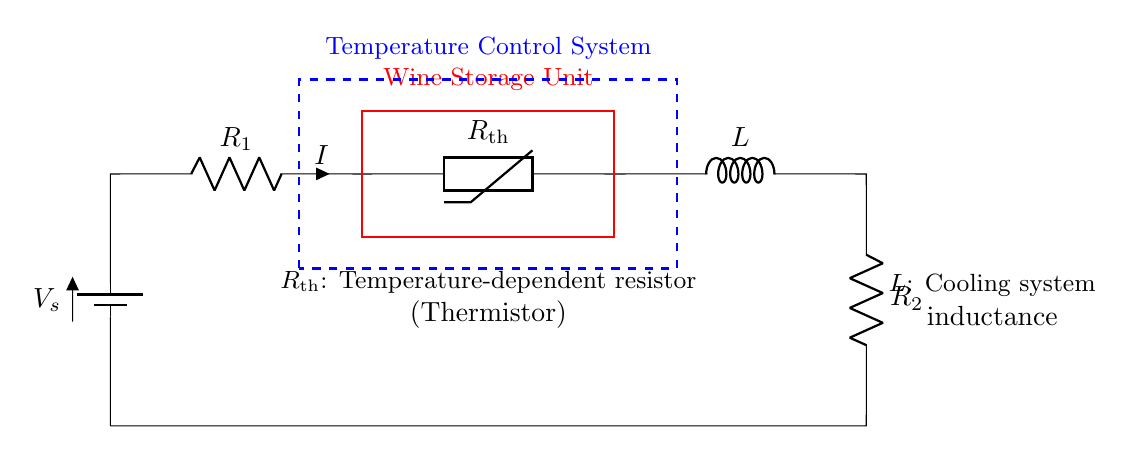What type of circuit is depicted? This circuit is a series circuit, as all components are connected in a single path, and the current flows through each component consecutively.
Answer: series circuit What component is represented by R1? R1 represents a resistor in the circuit, which is a passive component used to limit the flow of current.
Answer: resistor What does R_th signify? R_th signifies a thermistor, which is a temperature-dependent resistor that changes resistance based on the temperature, helping in the temperature control of the wine storage unit.
Answer: thermistor How many resistors are in this circuit? The circuit includes two resistors, R1 and R2, which control the current flow and can affect the voltage drop in the circuit.
Answer: two What is the function of L in this circuit? L represents the cooling system inductance, which is responsible for managing the inductive load in the temperature control system, ensuring efficient cooling.
Answer: cooling system How is the wine storage unit connected in the circuit? The wine storage unit is connected between the terminals of the thermistor and the inductive load, indicating that it is part of the feedback system that reacts to temperature changes.
Answer: feedback system What happens to current if temperature increases? If the temperature increases, the resistance of the thermistor (R_th) will decrease, leading to an increase in current through the circuit, affecting the cooling system's operation.
Answer: increase in current 